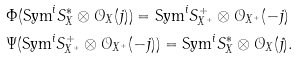Convert formula to latex. <formula><loc_0><loc_0><loc_500><loc_500>& \Phi ( \text {Sym} ^ { i } S ^ { * } _ { X } \otimes \mathcal { O } _ { X } ( j ) ) = \text {Sym} ^ { i } S ^ { + } _ { X ^ { + } } \otimes \mathcal { O } _ { X ^ { + } } ( - j ) \\ & \Psi ( \text {Sym} ^ { i } S ^ { + } _ { X ^ { + } } \otimes \mathcal { O } _ { X ^ { + } } ( - j ) ) = \text {Sym} ^ { i } S ^ { * } _ { X } \otimes \mathcal { O } _ { X } ( j ) .</formula> 